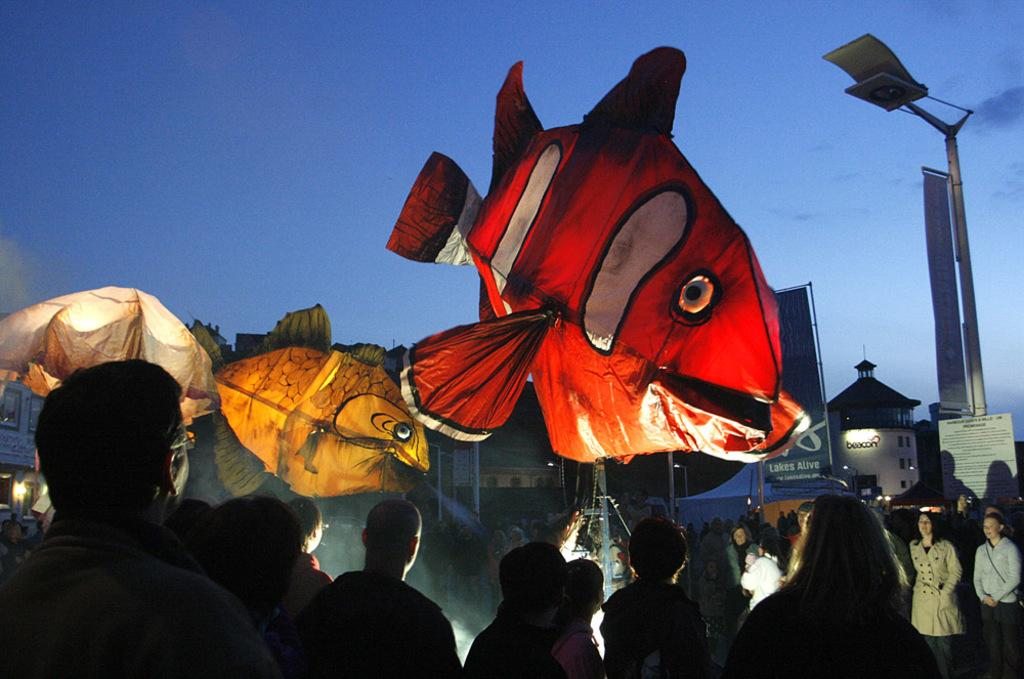What can be seen in the image? There are people standing in the image. What is present in the background of the image? There are fish balloons, poles, a building, and the sky visible in the background of the image. What type of milk is being served to the people in the image? There is no milk present in the image; it features people standing and various background elements. 